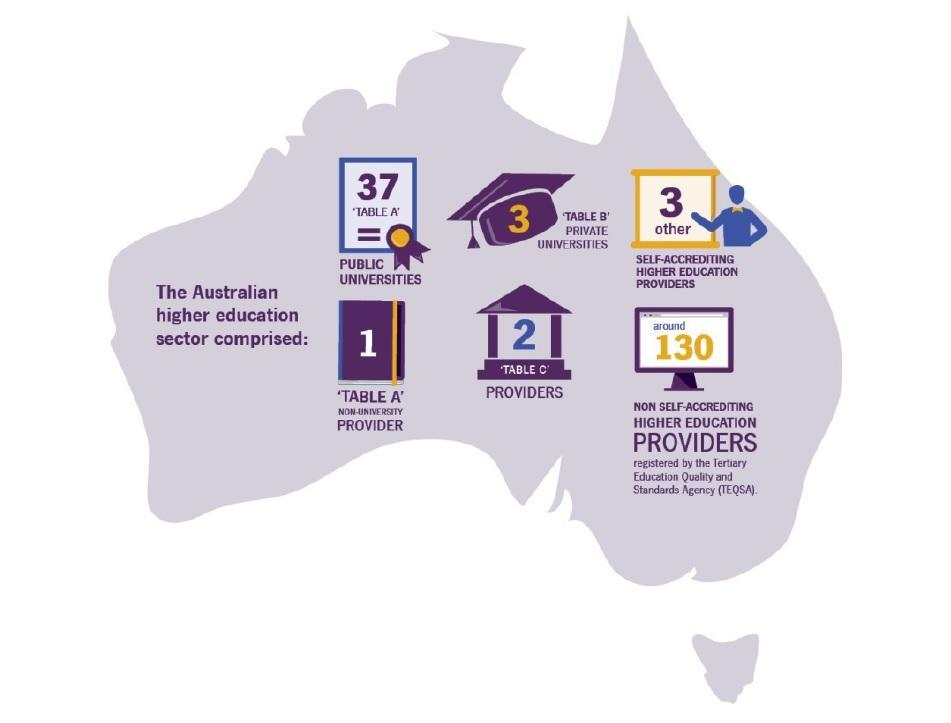How many Universities or Providers are listed under Australian higher education sector?
Answer the question with a short phrase. 6 